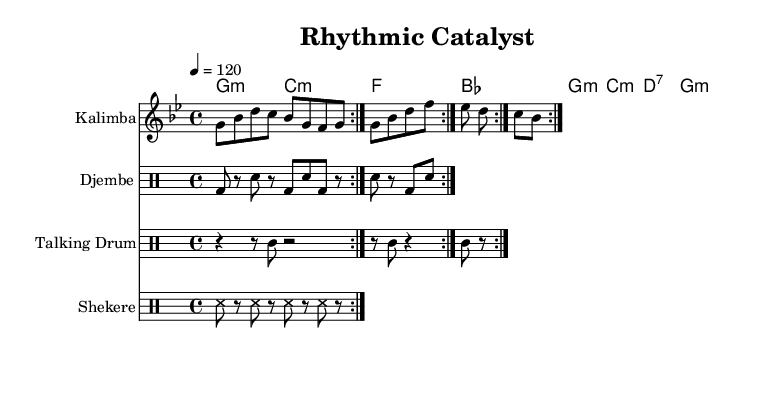What is the key signature of this music? The key signature is indicated at the beginning of the score. It shows one flat, which corresponds to G minor.
Answer: G minor What is the time signature of this music? The time signature appears at the beginning of the score as well. It is indicated as 4/4, meaning there are four beats per measure.
Answer: 4/4 What is the tempo marking, and what does it indicate? The tempo marking is found at the start of the score, indicated as "4 = 120". This means there are 120 beats per minute.
Answer: 120 How many measures are in the djembe part? The djembe part repeats a total of two times for a total of eight measures (as there are four measures in each repeat).
Answer: 8 Which drum plays the rhythm with a "tt" note? The rhythm containing "tt" notes is played by the talking drum. This notation appears in the staff designated for the talking drum.
Answer: Talking drum What unique aspect does shekere add to this composition? The shekere pattern consists entirely of sustained "ss" notes and rests, providing a distinct texture that contrasts with the other drums.
Answer: Sustained texture How do the kalimba and kora interact in this composition? The kalimba plays melodic lines while the kora provides harmonic support through chords, creating a blend of melody and harmony.
Answer: Blended melody and harmony 